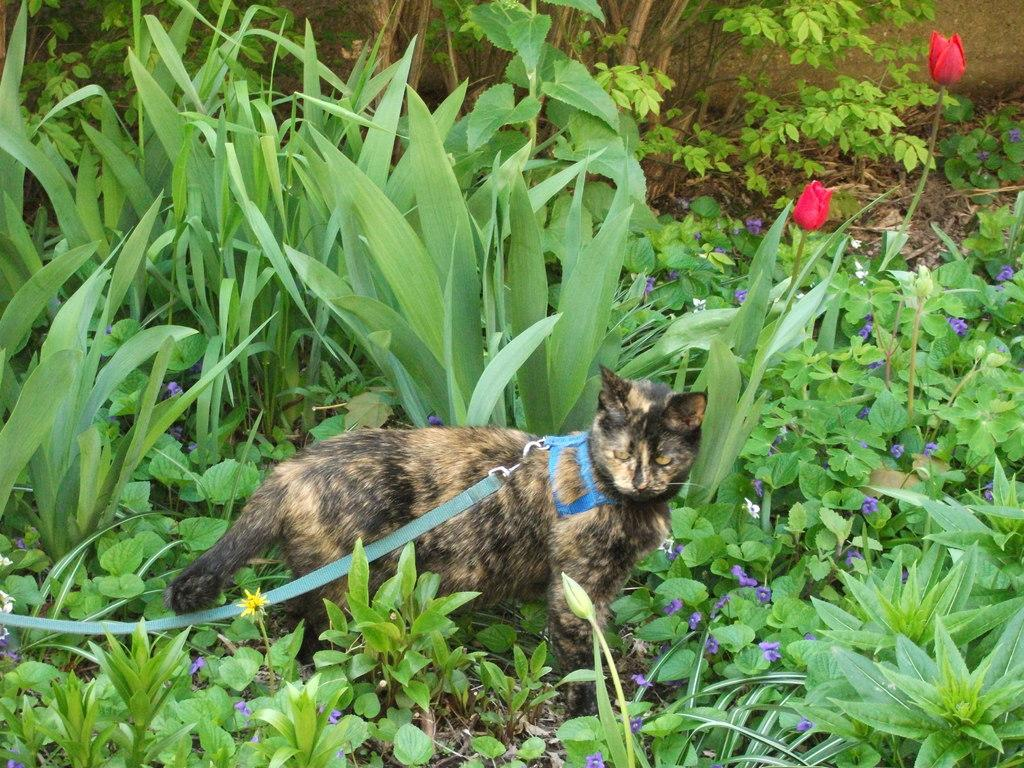What animal can be seen on the ground in the image? There is a cat on the ground in the image. What type of vegetation is visible in the background of the image? There are plants, trees, and flowers in the background of the image. What type of toys can be seen being played with by the cat in the image? There are no toys present in the image, and the cat is not shown playing with any. Can you see a snake in the image? There is no snake present in the image. 